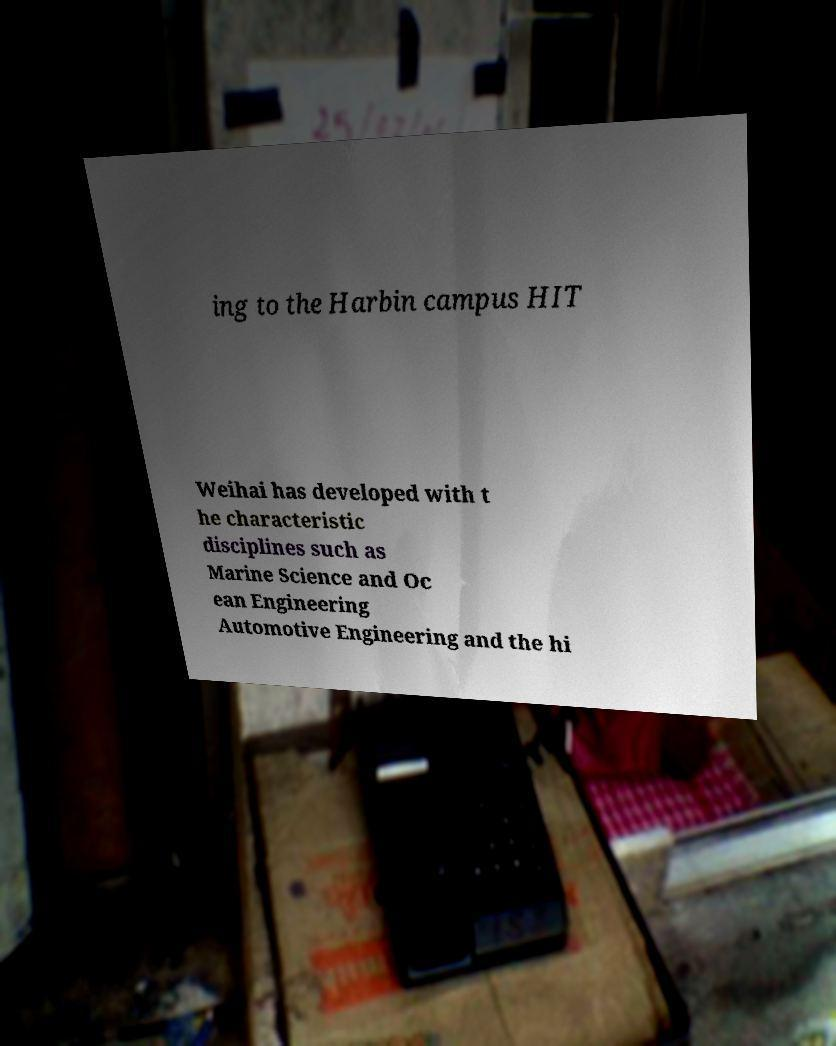Can you accurately transcribe the text from the provided image for me? ing to the Harbin campus HIT Weihai has developed with t he characteristic disciplines such as Marine Science and Oc ean Engineering Automotive Engineering and the hi 